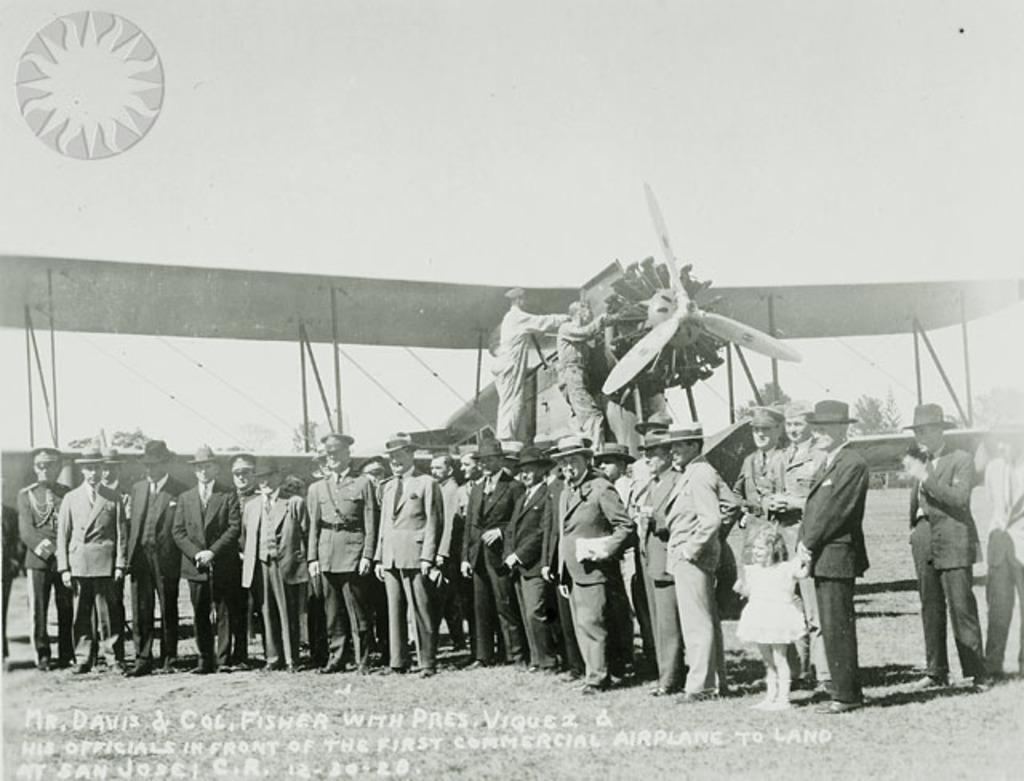Provide a one-sentence caption for the provided image. The men are standing in front of the first commercial airplane to land at San Jose. 